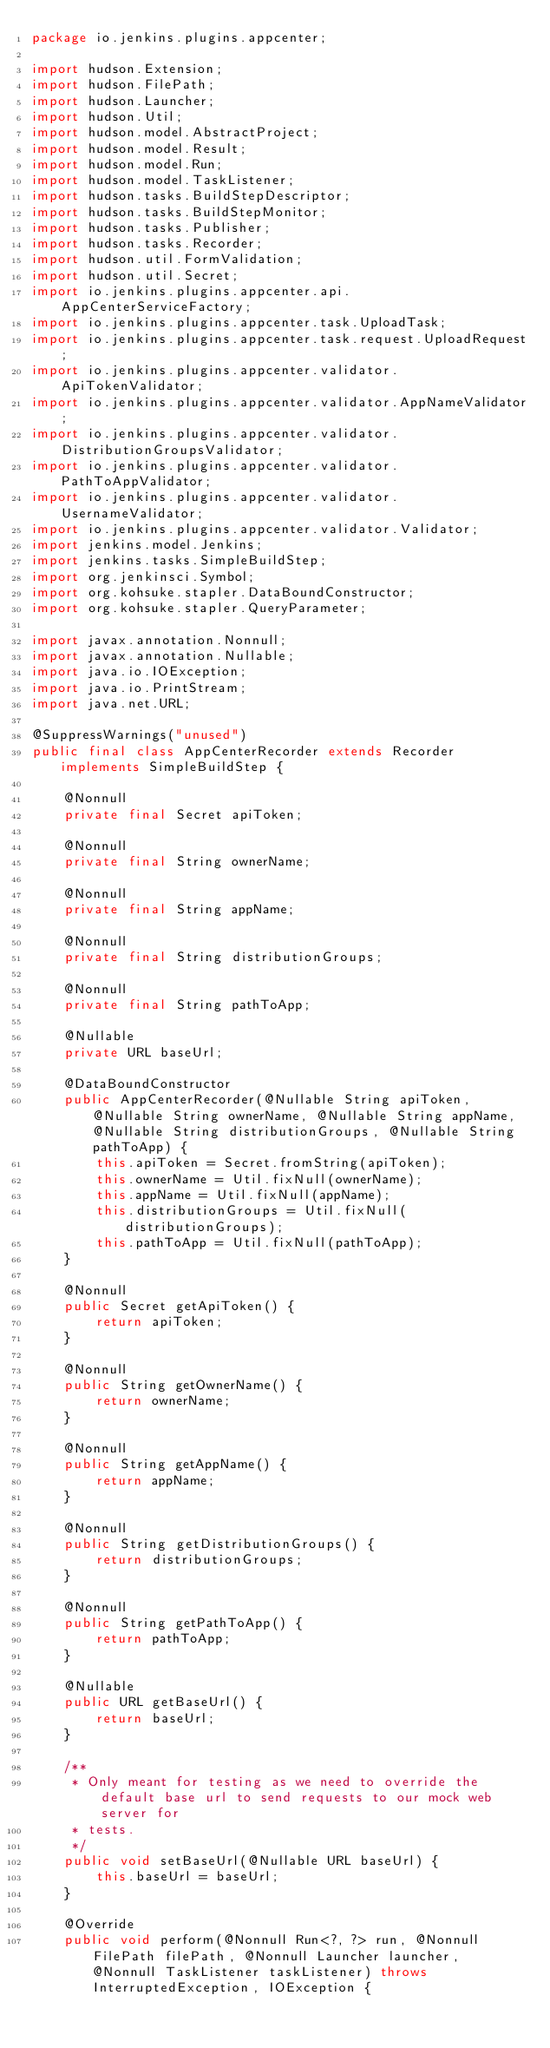<code> <loc_0><loc_0><loc_500><loc_500><_Java_>package io.jenkins.plugins.appcenter;

import hudson.Extension;
import hudson.FilePath;
import hudson.Launcher;
import hudson.Util;
import hudson.model.AbstractProject;
import hudson.model.Result;
import hudson.model.Run;
import hudson.model.TaskListener;
import hudson.tasks.BuildStepDescriptor;
import hudson.tasks.BuildStepMonitor;
import hudson.tasks.Publisher;
import hudson.tasks.Recorder;
import hudson.util.FormValidation;
import hudson.util.Secret;
import io.jenkins.plugins.appcenter.api.AppCenterServiceFactory;
import io.jenkins.plugins.appcenter.task.UploadTask;
import io.jenkins.plugins.appcenter.task.request.UploadRequest;
import io.jenkins.plugins.appcenter.validator.ApiTokenValidator;
import io.jenkins.plugins.appcenter.validator.AppNameValidator;
import io.jenkins.plugins.appcenter.validator.DistributionGroupsValidator;
import io.jenkins.plugins.appcenter.validator.PathToAppValidator;
import io.jenkins.plugins.appcenter.validator.UsernameValidator;
import io.jenkins.plugins.appcenter.validator.Validator;
import jenkins.model.Jenkins;
import jenkins.tasks.SimpleBuildStep;
import org.jenkinsci.Symbol;
import org.kohsuke.stapler.DataBoundConstructor;
import org.kohsuke.stapler.QueryParameter;

import javax.annotation.Nonnull;
import javax.annotation.Nullable;
import java.io.IOException;
import java.io.PrintStream;
import java.net.URL;

@SuppressWarnings("unused")
public final class AppCenterRecorder extends Recorder implements SimpleBuildStep {

    @Nonnull
    private final Secret apiToken;

    @Nonnull
    private final String ownerName;

    @Nonnull
    private final String appName;

    @Nonnull
    private final String distributionGroups;

    @Nonnull
    private final String pathToApp;

    @Nullable
    private URL baseUrl;

    @DataBoundConstructor
    public AppCenterRecorder(@Nullable String apiToken, @Nullable String ownerName, @Nullable String appName, @Nullable String distributionGroups, @Nullable String pathToApp) {
        this.apiToken = Secret.fromString(apiToken);
        this.ownerName = Util.fixNull(ownerName);
        this.appName = Util.fixNull(appName);
        this.distributionGroups = Util.fixNull(distributionGroups);
        this.pathToApp = Util.fixNull(pathToApp);
    }

    @Nonnull
    public Secret getApiToken() {
        return apiToken;
    }

    @Nonnull
    public String getOwnerName() {
        return ownerName;
    }

    @Nonnull
    public String getAppName() {
        return appName;
    }

    @Nonnull
    public String getDistributionGroups() {
        return distributionGroups;
    }

    @Nonnull
    public String getPathToApp() {
        return pathToApp;
    }

    @Nullable
    public URL getBaseUrl() {
        return baseUrl;
    }

    /**
     * Only meant for testing as we need to override the default base url to send requests to our mock web server for
     * tests.
     */
    public void setBaseUrl(@Nullable URL baseUrl) {
        this.baseUrl = baseUrl;
    }

    @Override
    public void perform(@Nonnull Run<?, ?> run, @Nonnull FilePath filePath, @Nonnull Launcher launcher, @Nonnull TaskListener taskListener) throws InterruptedException, IOException {</code> 